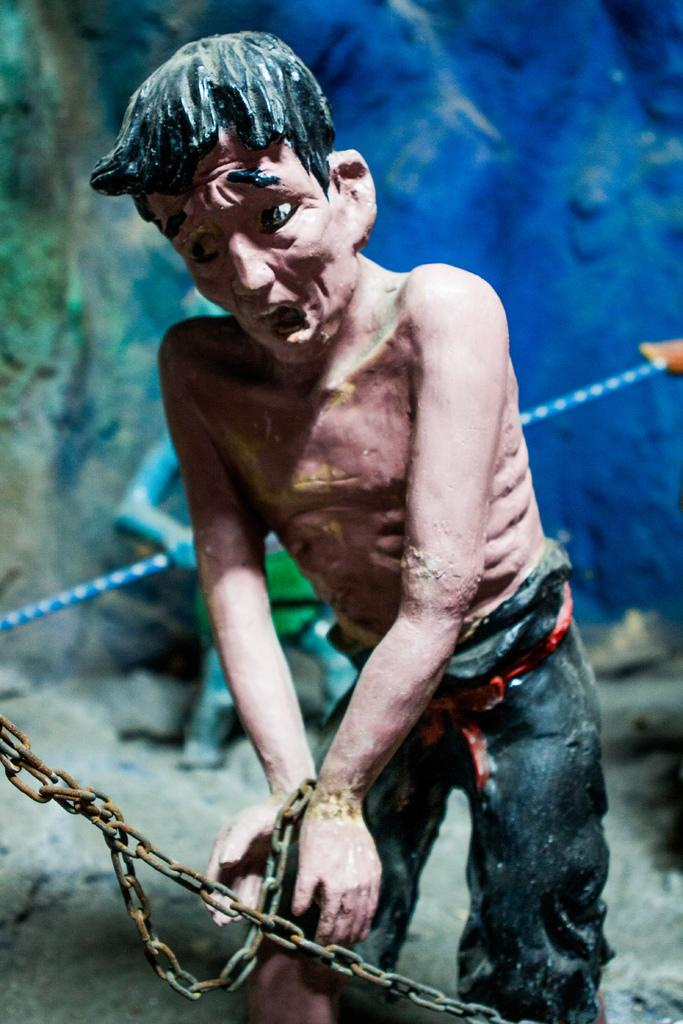What is located at the bottom of the image? There is a fencing at the bottom of the image. What can be seen behind the fencing? There is a sculpture behind the fencing. What is located behind the sculpture? There is a stone behind the sculpture. Can you tell me how many goldfish are swimming in the stone in the image? There are no goldfish present in the image; it features a stone behind a sculpture. Is the current of water affecting the sculpture in the image? There is no mention of water or current in the image, so it cannot be determined if it is affecting the sculpture. 